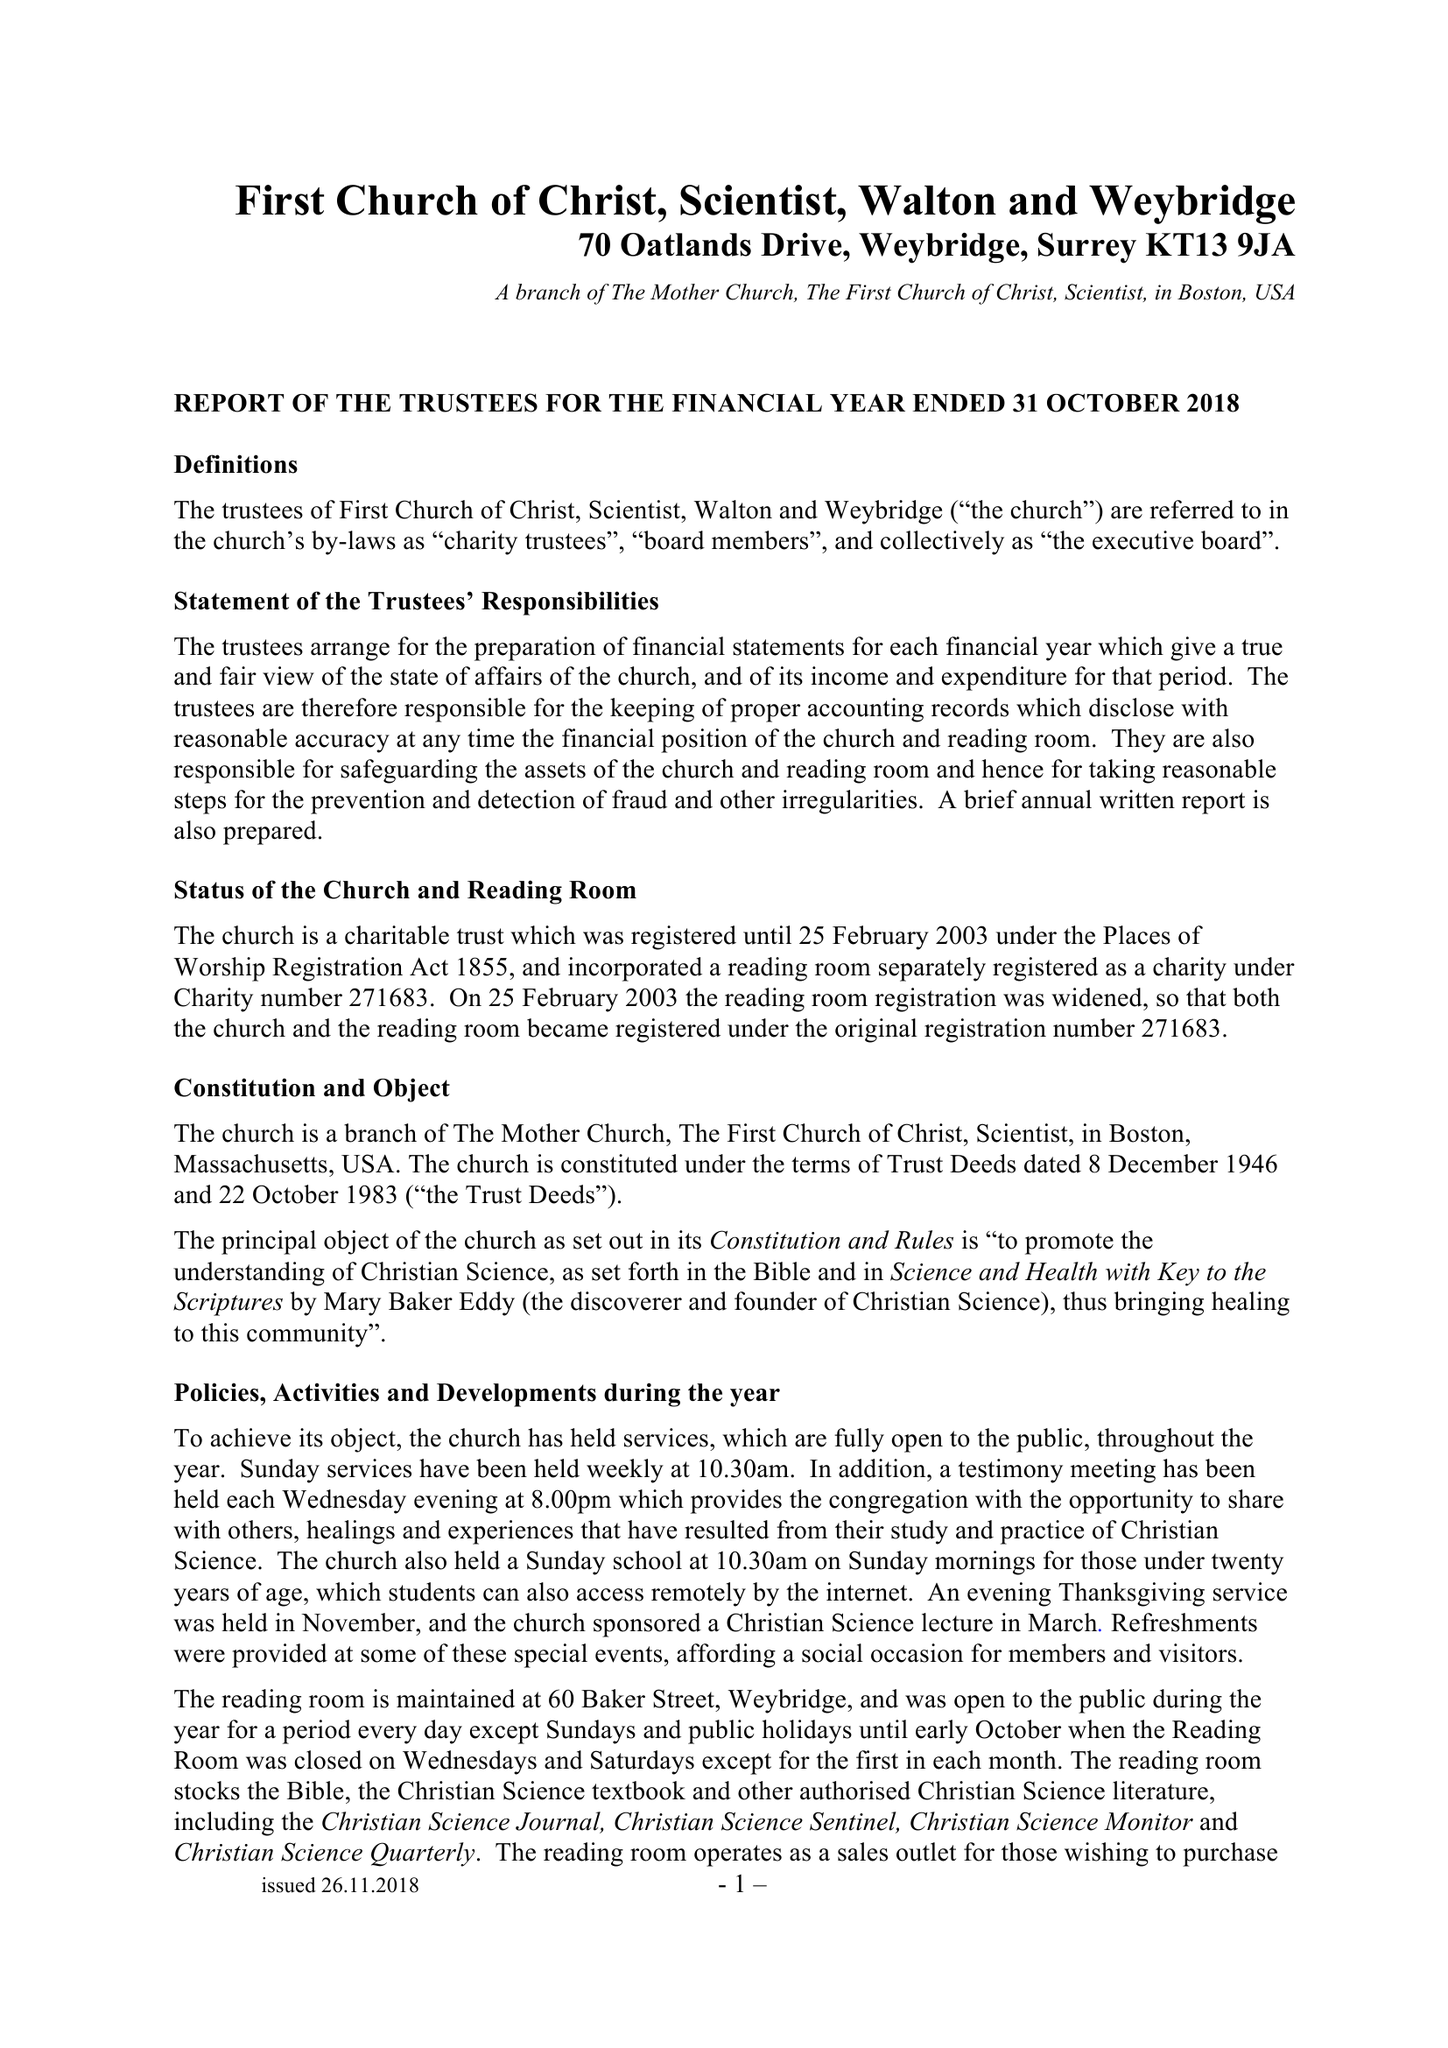What is the value for the address__post_town?
Answer the question using a single word or phrase. WEYBRIDGE 